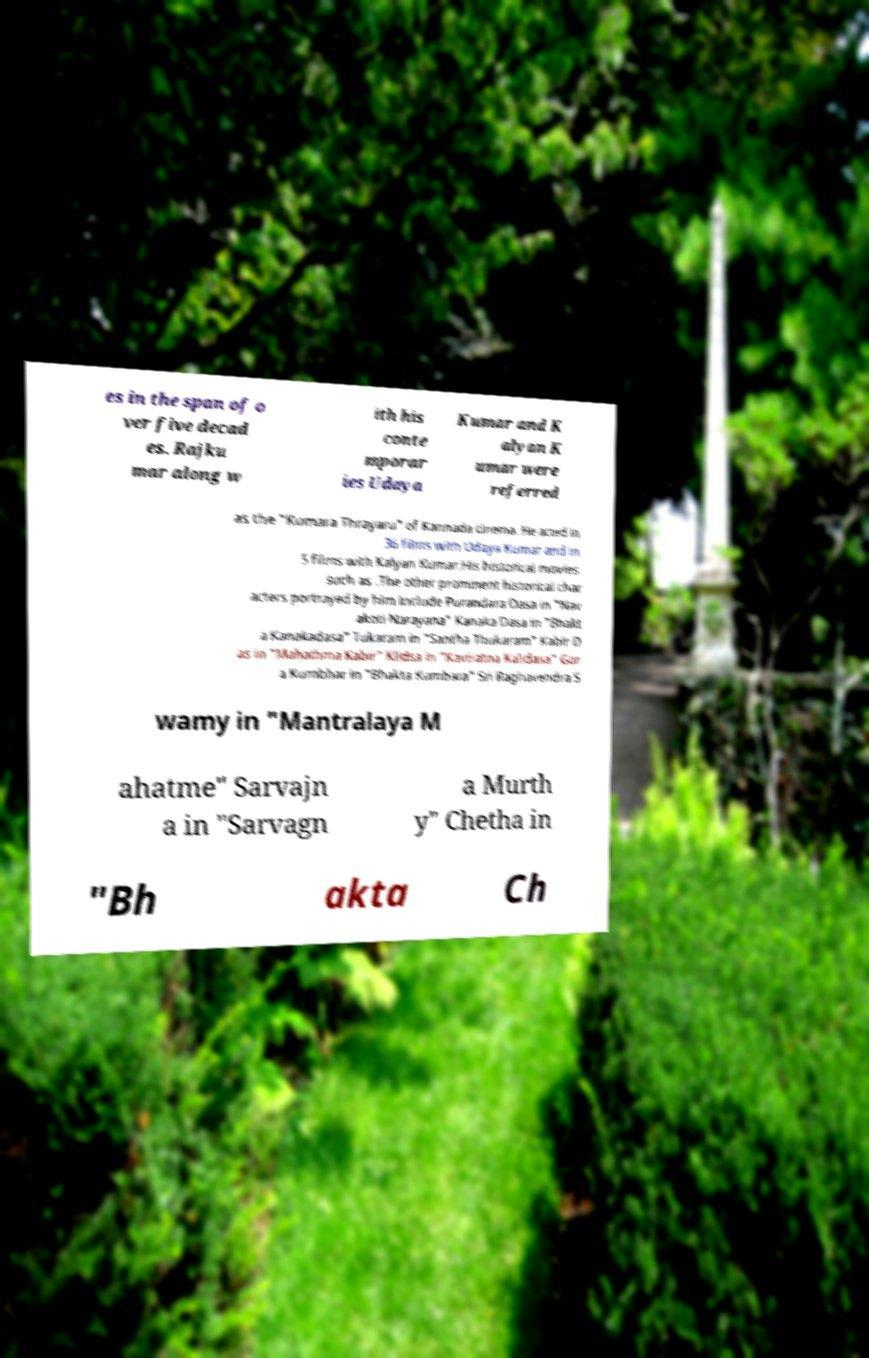Can you read and provide the text displayed in the image?This photo seems to have some interesting text. Can you extract and type it out for me? es in the span of o ver five decad es. Rajku mar along w ith his conte mporar ies Udaya Kumar and K alyan K umar were referred as the "Kumara Thrayaru" of Kannada cinema. He acted in 36 films with Udaya Kumar and in 5 films with Kalyan Kumar.His historical movies such as .The other prominent historical char acters portrayed by him include Purandara Dasa in "Nav akoti Narayana" Kanaka Dasa in "Bhakt a Kanakadasa" Tukaram in "Santha Thukaram" Kabir D as in "Mahathma Kabir" Klidsa in "Kaviratna Kalidasa" Gor a Kumbhar in "Bhakta Kumbara" Sri Raghavendra S wamy in "Mantralaya M ahatme" Sarvajn a in "Sarvagn a Murth y" Chetha in "Bh akta Ch 